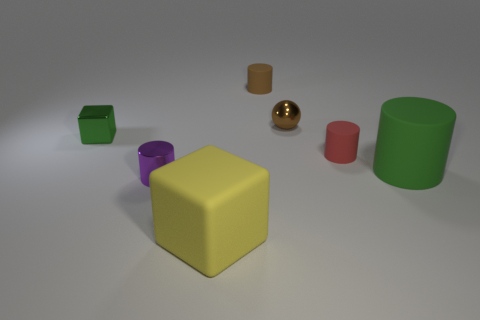How are the objects arranged in the space? The objects are scattered across a flat surface with no apparent pattern. The yellow cube is central and the other objects are positioned around it at varying distances, creating a visually balanced composition. 